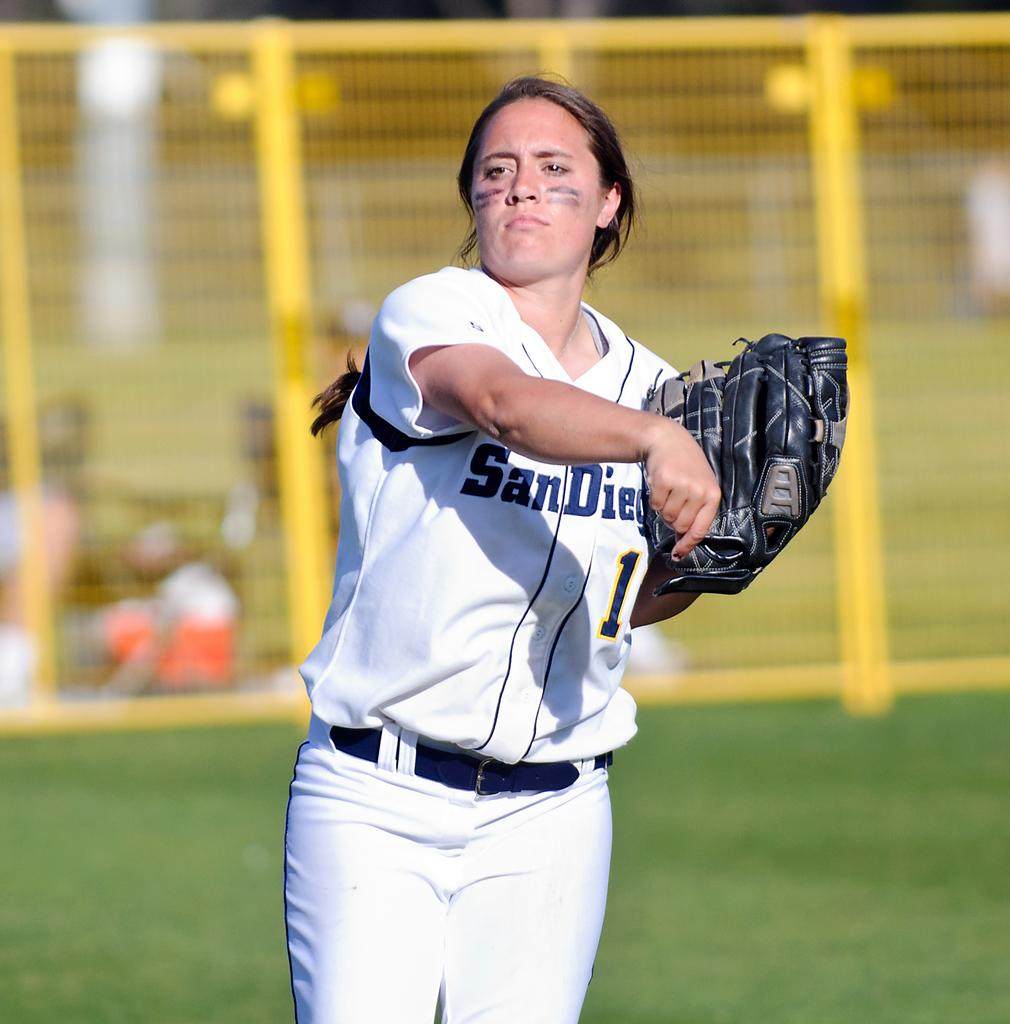<image>
Offer a succinct explanation of the picture presented. a lady with san diego on her jersey 